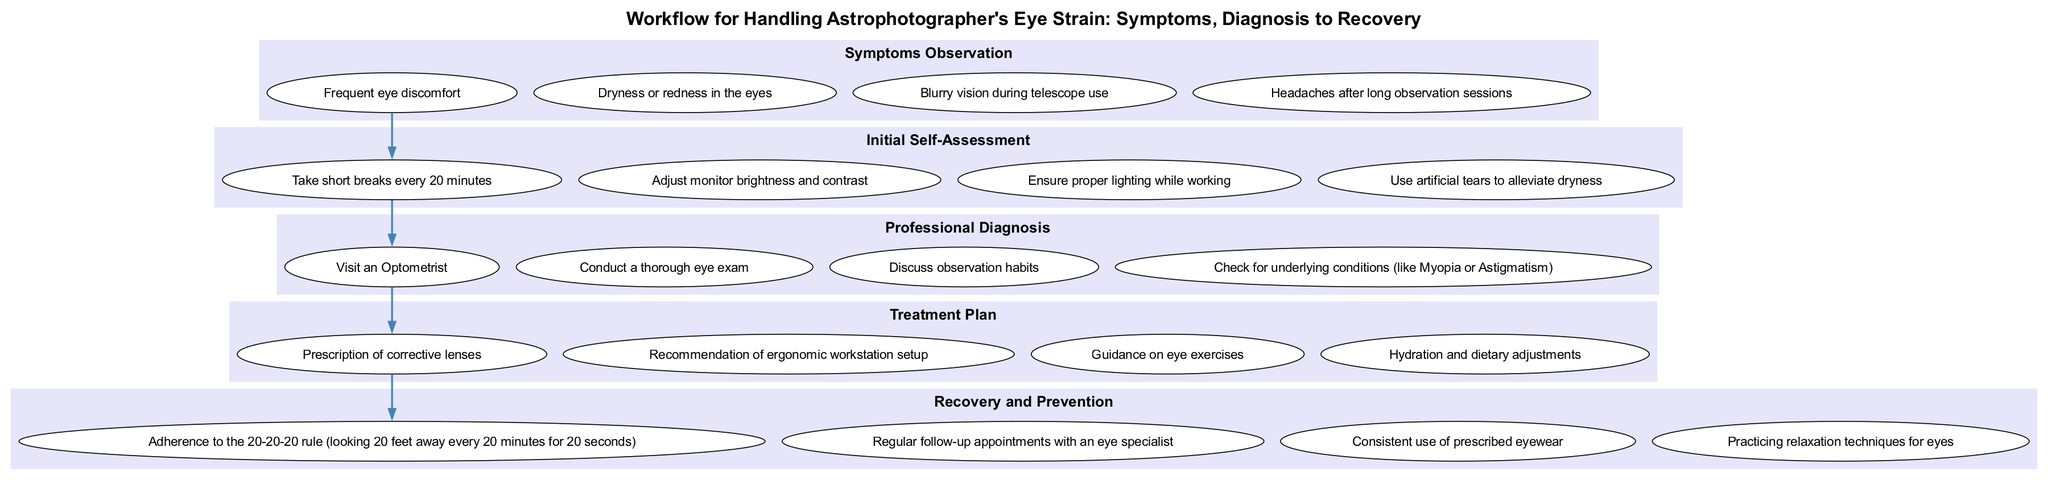What is the first stage in the workflow? The diagram starts with the first stage labeled "Symptoms Observation," which is clearly indicated and presents the initial step in addressing eye strain.
Answer: Symptoms Observation How many symptoms are listed under the Symptoms Observation stage? There are four specific elements detailing the symptoms listed under the Symptoms Observation stage, which can be counted directly from the diagram.
Answer: 4 What is the last stage in the recovery process? The diagram presents "Recovery and Prevention" as the final stage, emphasizing the importance of long-term care and practices after initial treatment.
Answer: Recovery and Prevention What is one of the elements in the Treatment Plan? In the Treatment Plan stage, one element is "Prescription of corrective lenses," which is explicitly mentioned and serves as an important aspect of the treatment process.
Answer: Prescription of corrective lenses Which stage comes after the Initial Self-Assessment? The flow from the diagram indicates that the stage following Initial Self-Assessment is "Professional Diagnosis," clearly connecting the two stages sequentially.
Answer: Professional Diagnosis How many elements are there in the Recovery and Prevention stage? There are four distinct elements outlined in the Recovery and Prevention stage, as indicated by the diagram.
Answer: 4 What is a recommended practice during Initial Self-Assessment? One of the recommended practices is "Take short breaks every 20 minutes," which is one of the elements listed in the Initial Self-Assessment stage.
Answer: Take short breaks every 20 minutes How many connections (edges) are there between stages in the workflow? The connections shown in the diagram imply there are four edges linking the five distinct stages in this clinical pathway, providing a clear flow of process.
Answer: 4 